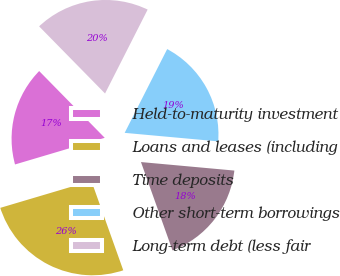Convert chart to OTSL. <chart><loc_0><loc_0><loc_500><loc_500><pie_chart><fcel>Held-to-maturity investment<fcel>Loans and leases (including<fcel>Time deposits<fcel>Other short-term borrowings<fcel>Long-term debt (less fair<nl><fcel>17.24%<fcel>25.86%<fcel>18.1%<fcel>18.97%<fcel>19.83%<nl></chart> 